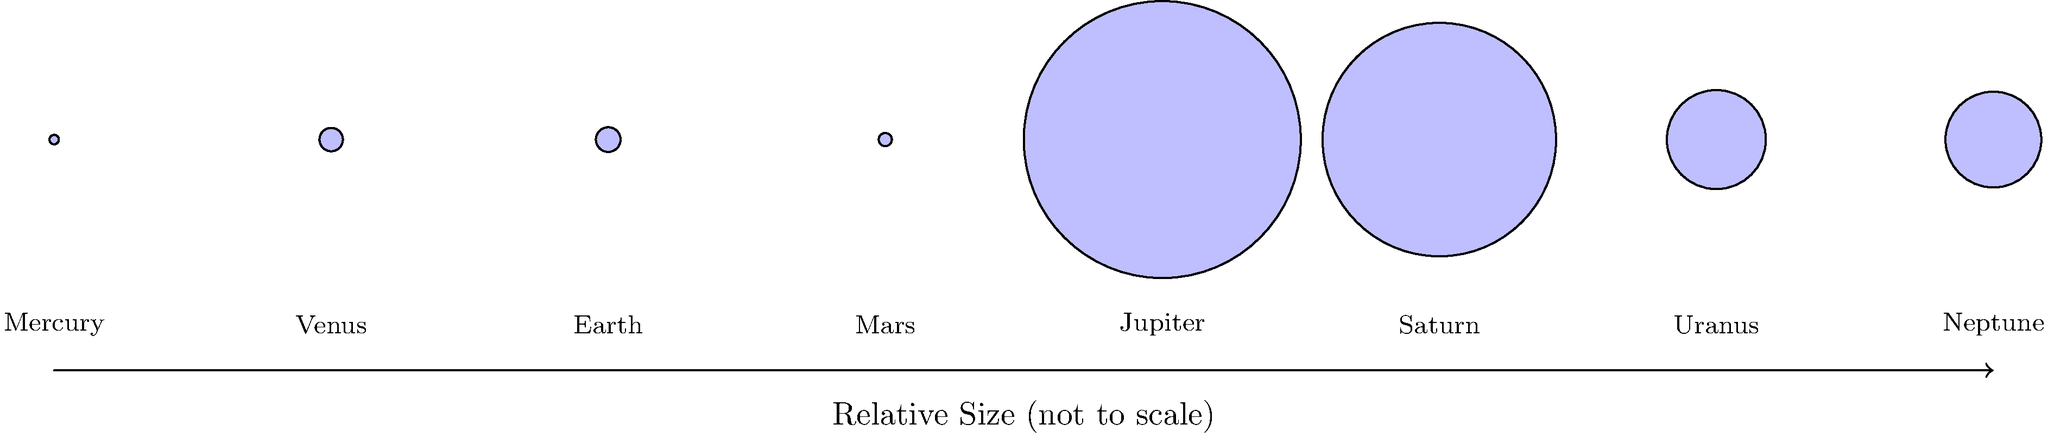As an amateur astronomer fascinated by the diverse celestial bodies in our solar system, you're studying the relative sizes of planets. Based on the diagram, which planet is approximately 11 times larger than Earth in diameter? To answer this question, let's follow these steps:

1. Observe the diagram, which shows the relative sizes of planets in our solar system.
2. The sizes are not to scale but represent the proportional differences between planets.
3. Earth is used as a reference point with a relative size of 1.
4. Look for a planet that appears significantly larger than the others.
5. Compare the sizes of the larger planets to Earth:
   - Jupiter: appears to be the largest
   - Saturn: slightly smaller than Jupiter
   - Uranus and Neptune: noticeably smaller than Jupiter and Saturn
6. Focus on Jupiter, as it's visibly the largest planet in the diagram.
7. Check the relative size of Jupiter compared to Earth:
   - Jupiter's circle is about 11 times larger in diameter than Earth's circle.
8. This matches the description in the question of being "approximately 11 times larger than Earth in diameter."

Therefore, based on the relative sizes shown in the diagram, Jupiter is the planet that is approximately 11 times larger than Earth in diameter.
Answer: Jupiter 